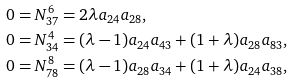<formula> <loc_0><loc_0><loc_500><loc_500>& 0 = N _ { 3 7 } ^ { 6 } = 2 \lambda a _ { 2 4 } a _ { 2 8 } , \\ & 0 = N _ { 3 4 } ^ { 4 } = ( \lambda - 1 ) a _ { 2 4 } a _ { 4 3 } + ( 1 + \lambda ) a _ { 2 8 } a _ { 8 3 } , \\ & 0 = N _ { 7 8 } ^ { 8 } = ( \lambda - 1 ) a _ { 2 8 } a _ { 3 4 } + ( 1 + \lambda ) a _ { 2 4 } a _ { 3 8 } ,</formula> 